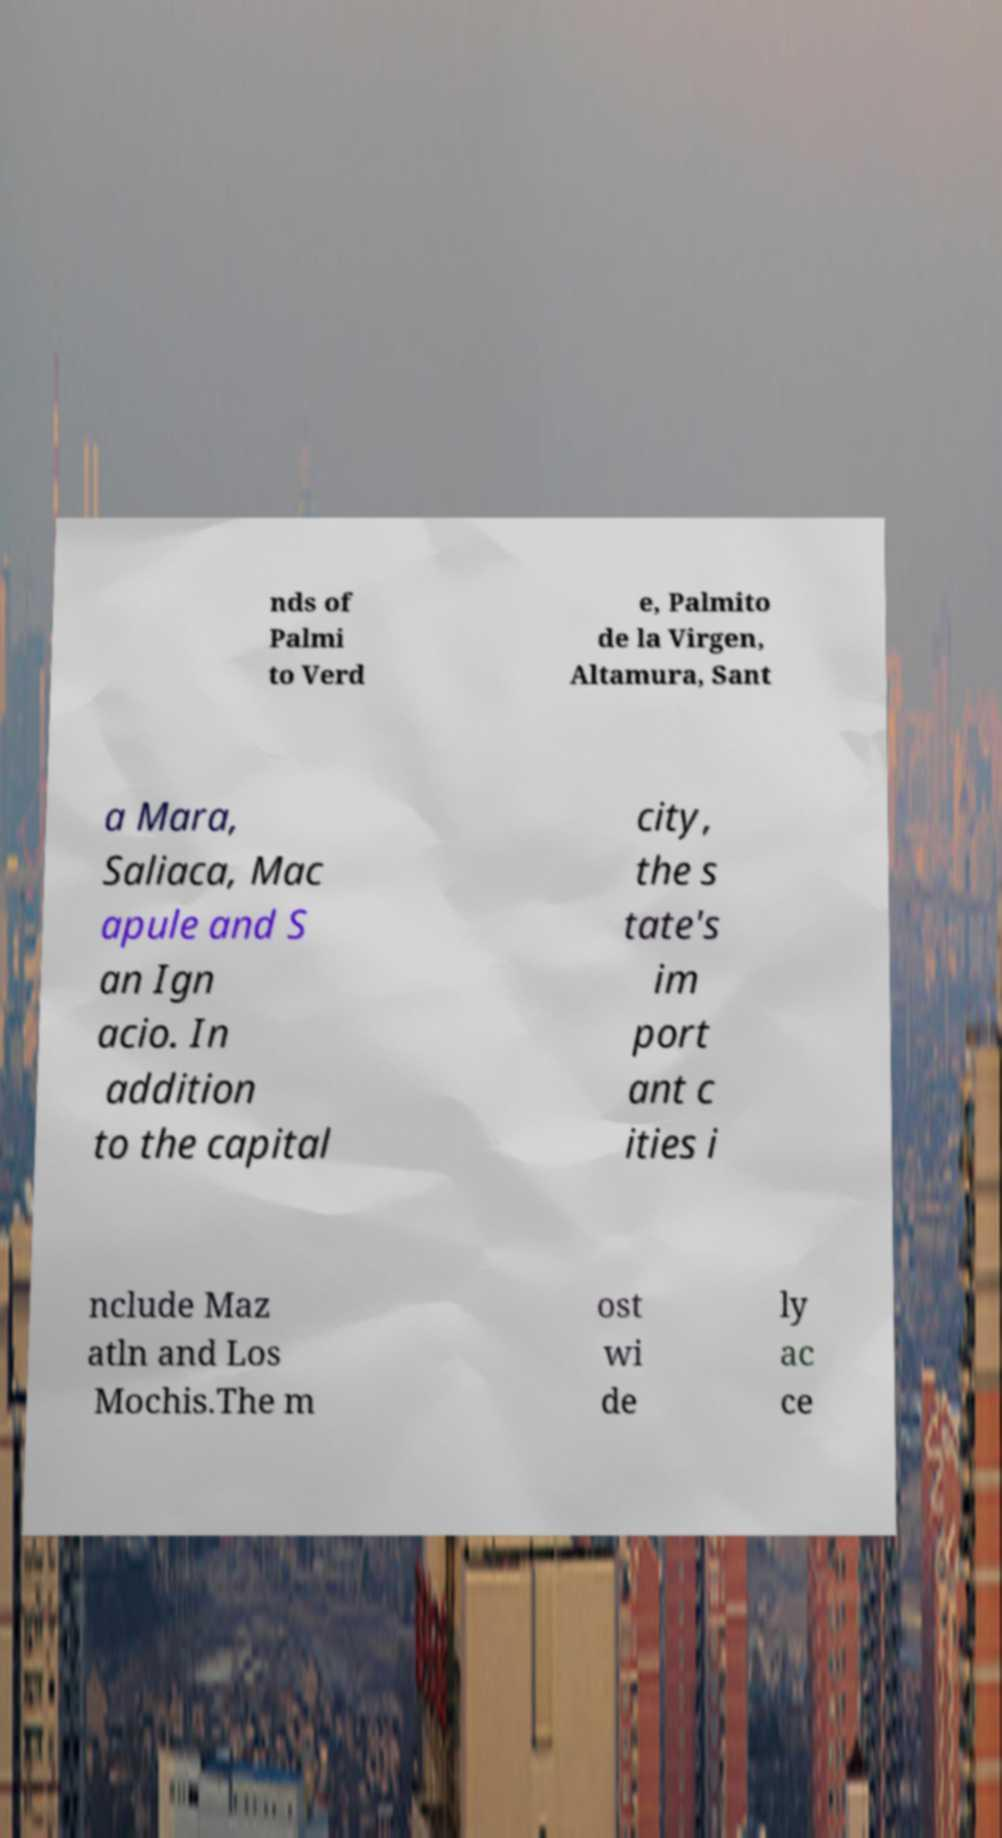What messages or text are displayed in this image? I need them in a readable, typed format. nds of Palmi to Verd e, Palmito de la Virgen, Altamura, Sant a Mara, Saliaca, Mac apule and S an Ign acio. In addition to the capital city, the s tate's im port ant c ities i nclude Maz atln and Los Mochis.The m ost wi de ly ac ce 